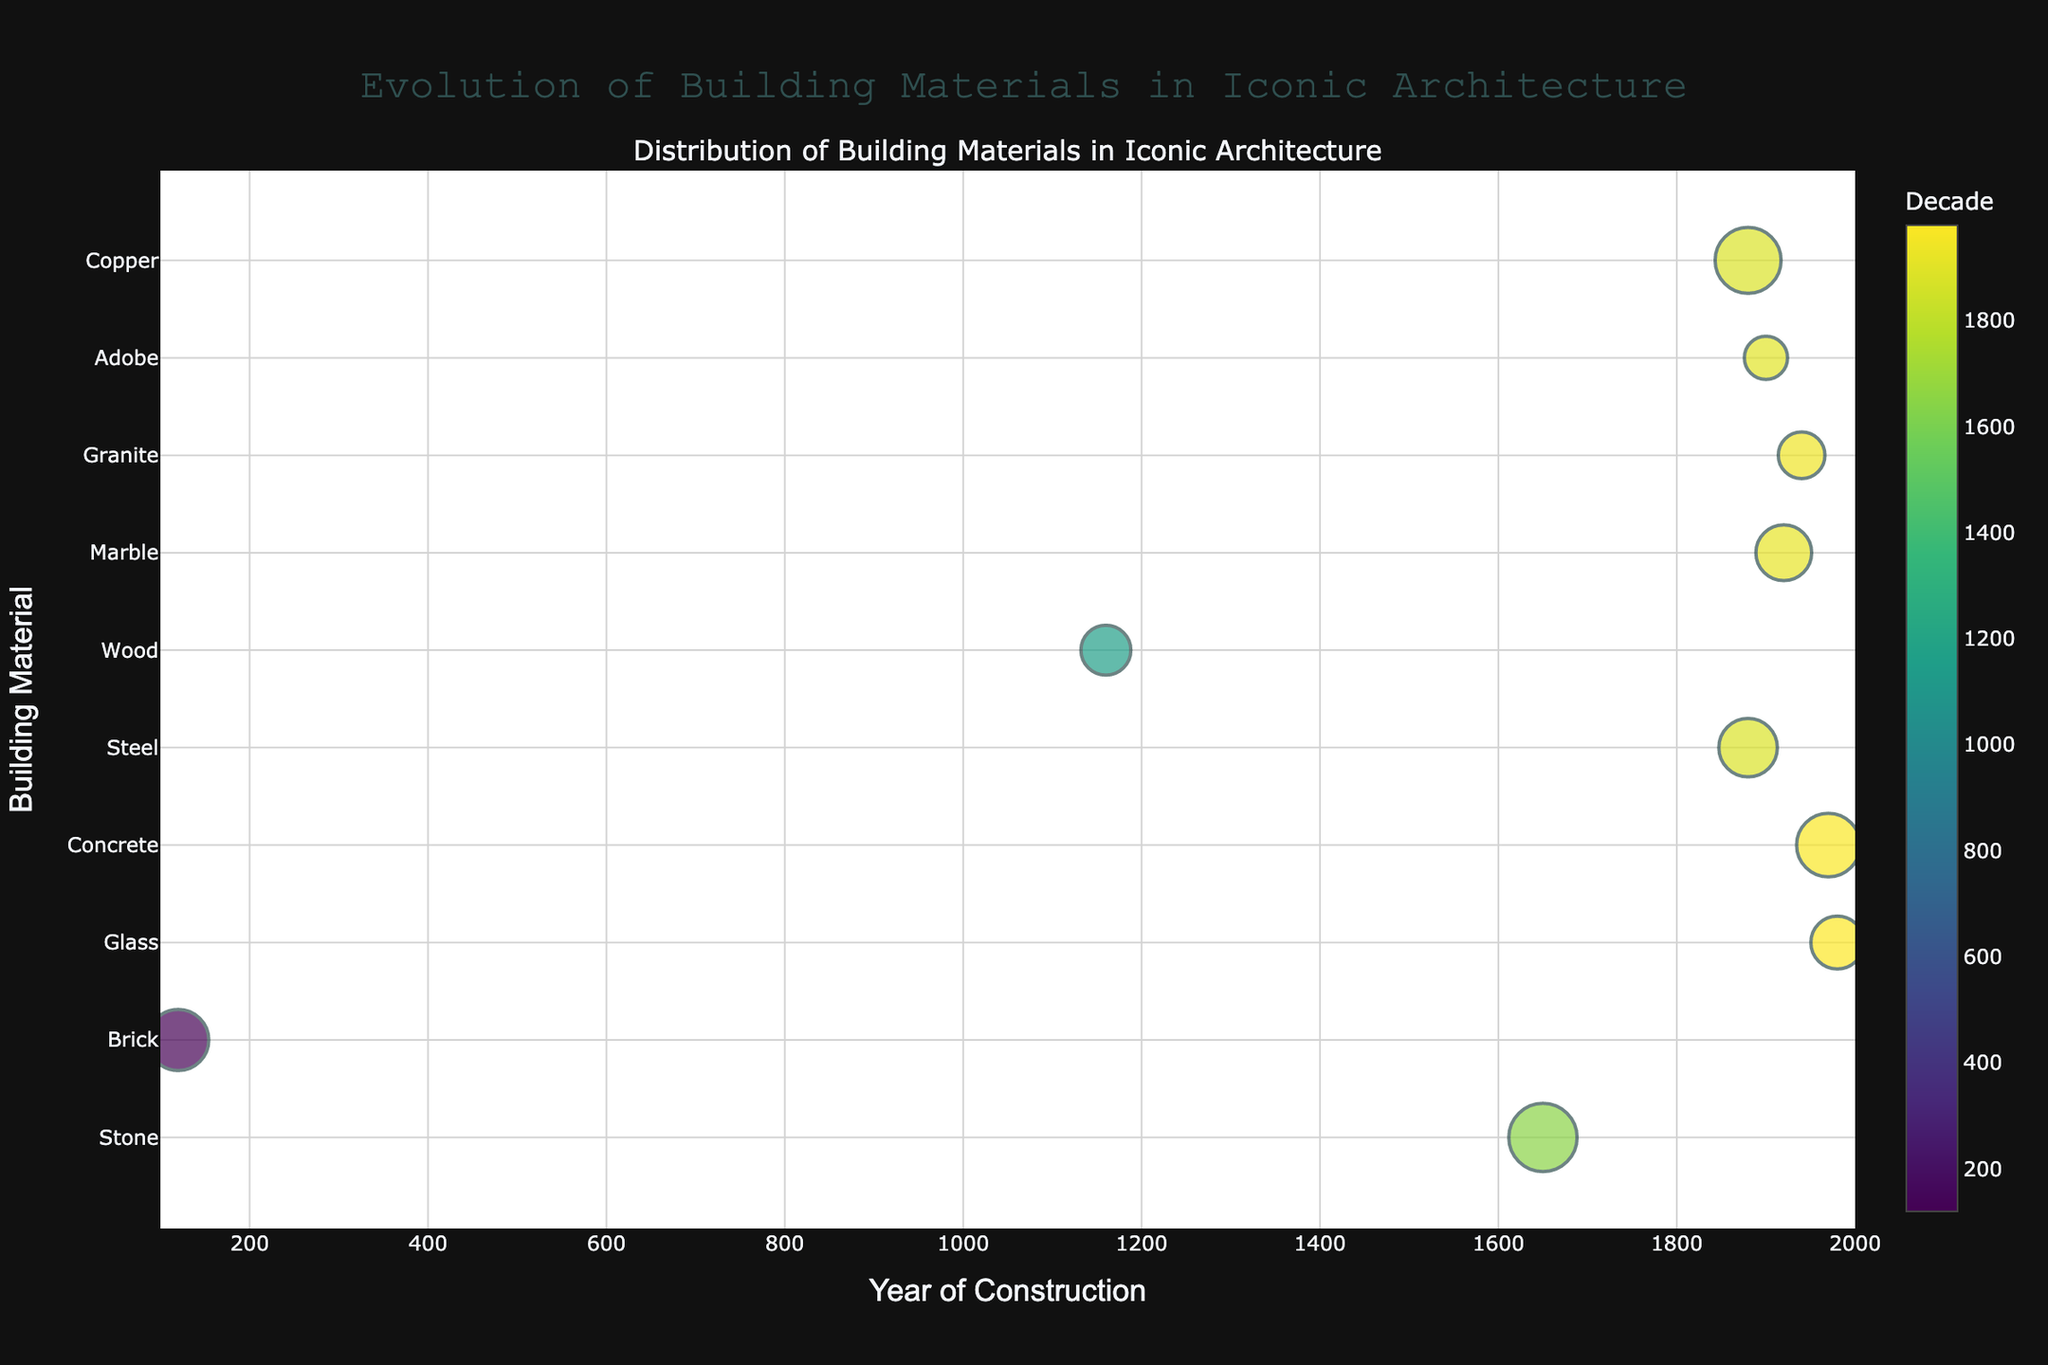What's the title of the figure? The title of the figure is displayed at the top and reads "Evolution of Building Materials in Iconic Architecture".
Answer: Evolution of Building Materials in Iconic Architecture Which material is associated with the tallest bubble? The bubble sizes correspond to the 'BubbleSize' column, where the tallest bubble would have the largest BubbleSize. The largest BubbleSize is 150, which is associated with Stone used in the Taj Mahal.
Answer: Stone How are different decades represented in the figure? Different decades are represented by varying colors on a continuous Viridis color scale.
Answer: colors on a Viridis scale Which building material has been used most recently according to the plot? To find the most recent building material, look for the highest 'Decade' value in the x-axis. The Glass used in The Louvre Pyramid in France with a decade of 1980 is the most recent.
Answer: Glass What information is provided when hovering over the bubbles? Hovering over the bubbles shows the building name and location. For example, hovering over the largest bubble shows "Taj Mahal, India".
Answer: building name and location How many building materials have been used in iconic architectures in the USA according to the plot? To find this, count the number of unique materials associated with buildings in the USA. The figure shows three USA buildings: Lincoln Memorial (Marble), Mount Rushmore (Granite), and Statue of Liberty (Copper).
Answer: 3 Which building material, represented by a bubble, appears in the oldest decade? Look for the lowest 'Decade' value on the x-axis. The building with Brick material (The Pantheon, Italy) dates back to the 120s.
Answer: Brick What's the decade of construction for the building with the smallest bubble? The smallest bubble corresponds to the smallest 'BubbleSize'. The smallest size, 60, is for Adobe used in the Great Mosque of Djenné (1900).
Answer: 1900 What is the average BubbleSize for the buildings made with Stone and Marble? Calculate the average of BubbleSize for Stone (150) and Marble (100). The steps are (150 + 100) / 2 = 125.
Answer: 125 Which material has the largest difference in BubbleSize when compared between two iconic buildings? Identify the maximum and minimum BubbleSizes, which are 150 (Stone, Taj Mahal) and 60 (Adobe, Great Mosque of Djenné). The difference is 150 - 60 = 90.
Answer: 90 